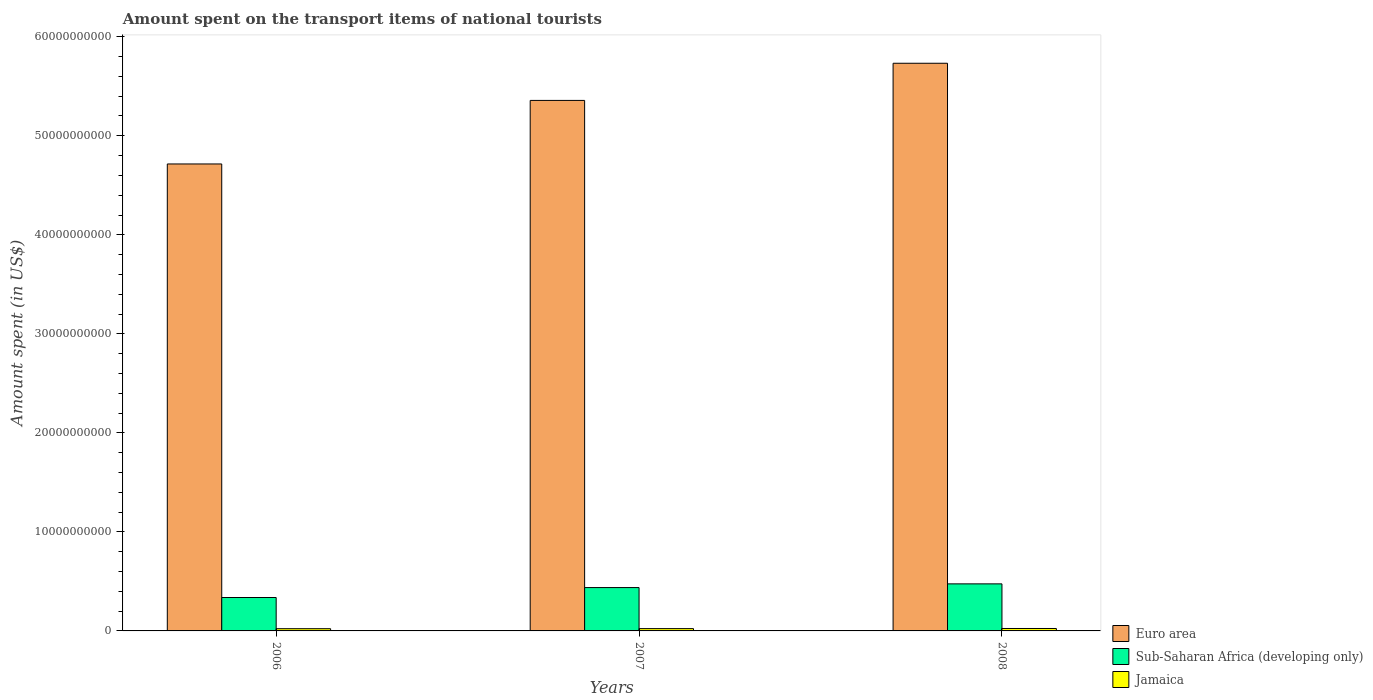Are the number of bars per tick equal to the number of legend labels?
Offer a very short reply. Yes. How many bars are there on the 3rd tick from the left?
Make the answer very short. 3. How many bars are there on the 2nd tick from the right?
Provide a short and direct response. 3. What is the amount spent on the transport items of national tourists in Jamaica in 2007?
Provide a short and direct response. 2.32e+08. Across all years, what is the maximum amount spent on the transport items of national tourists in Euro area?
Keep it short and to the point. 5.73e+1. Across all years, what is the minimum amount spent on the transport items of national tourists in Jamaica?
Provide a short and direct response. 2.24e+08. In which year was the amount spent on the transport items of national tourists in Euro area maximum?
Keep it short and to the point. 2008. In which year was the amount spent on the transport items of national tourists in Euro area minimum?
Offer a terse response. 2006. What is the total amount spent on the transport items of national tourists in Sub-Saharan Africa (developing only) in the graph?
Your answer should be compact. 1.25e+1. What is the difference between the amount spent on the transport items of national tourists in Euro area in 2006 and that in 2007?
Your response must be concise. -6.42e+09. What is the difference between the amount spent on the transport items of national tourists in Sub-Saharan Africa (developing only) in 2008 and the amount spent on the transport items of national tourists in Jamaica in 2006?
Give a very brief answer. 4.53e+09. What is the average amount spent on the transport items of national tourists in Jamaica per year?
Ensure brevity in your answer.  2.34e+08. In the year 2006, what is the difference between the amount spent on the transport items of national tourists in Euro area and amount spent on the transport items of national tourists in Sub-Saharan Africa (developing only)?
Offer a terse response. 4.38e+1. What is the ratio of the amount spent on the transport items of national tourists in Jamaica in 2007 to that in 2008?
Your response must be concise. 0.94. Is the difference between the amount spent on the transport items of national tourists in Euro area in 2006 and 2007 greater than the difference between the amount spent on the transport items of national tourists in Sub-Saharan Africa (developing only) in 2006 and 2007?
Provide a succinct answer. No. What is the difference between the highest and the second highest amount spent on the transport items of national tourists in Sub-Saharan Africa (developing only)?
Provide a succinct answer. 3.73e+08. What is the difference between the highest and the lowest amount spent on the transport items of national tourists in Euro area?
Give a very brief answer. 1.02e+1. In how many years, is the amount spent on the transport items of national tourists in Euro area greater than the average amount spent on the transport items of national tourists in Euro area taken over all years?
Make the answer very short. 2. What does the 2nd bar from the left in 2007 represents?
Your response must be concise. Sub-Saharan Africa (developing only). What does the 3rd bar from the right in 2006 represents?
Give a very brief answer. Euro area. How many years are there in the graph?
Give a very brief answer. 3. Are the values on the major ticks of Y-axis written in scientific E-notation?
Keep it short and to the point. No. Does the graph contain grids?
Your response must be concise. No. How are the legend labels stacked?
Ensure brevity in your answer.  Vertical. What is the title of the graph?
Your answer should be compact. Amount spent on the transport items of national tourists. Does "Portugal" appear as one of the legend labels in the graph?
Offer a very short reply. No. What is the label or title of the X-axis?
Offer a very short reply. Years. What is the label or title of the Y-axis?
Provide a short and direct response. Amount spent (in US$). What is the Amount spent (in US$) in Euro area in 2006?
Provide a succinct answer. 4.72e+1. What is the Amount spent (in US$) in Sub-Saharan Africa (developing only) in 2006?
Your answer should be compact. 3.37e+09. What is the Amount spent (in US$) of Jamaica in 2006?
Provide a succinct answer. 2.24e+08. What is the Amount spent (in US$) in Euro area in 2007?
Provide a short and direct response. 5.36e+1. What is the Amount spent (in US$) in Sub-Saharan Africa (developing only) in 2007?
Keep it short and to the point. 4.38e+09. What is the Amount spent (in US$) of Jamaica in 2007?
Offer a terse response. 2.32e+08. What is the Amount spent (in US$) of Euro area in 2008?
Your response must be concise. 5.73e+1. What is the Amount spent (in US$) in Sub-Saharan Africa (developing only) in 2008?
Your response must be concise. 4.75e+09. What is the Amount spent (in US$) in Jamaica in 2008?
Offer a terse response. 2.46e+08. Across all years, what is the maximum Amount spent (in US$) in Euro area?
Give a very brief answer. 5.73e+1. Across all years, what is the maximum Amount spent (in US$) of Sub-Saharan Africa (developing only)?
Your answer should be compact. 4.75e+09. Across all years, what is the maximum Amount spent (in US$) in Jamaica?
Offer a terse response. 2.46e+08. Across all years, what is the minimum Amount spent (in US$) in Euro area?
Keep it short and to the point. 4.72e+1. Across all years, what is the minimum Amount spent (in US$) in Sub-Saharan Africa (developing only)?
Provide a succinct answer. 3.37e+09. Across all years, what is the minimum Amount spent (in US$) in Jamaica?
Provide a short and direct response. 2.24e+08. What is the total Amount spent (in US$) in Euro area in the graph?
Ensure brevity in your answer.  1.58e+11. What is the total Amount spent (in US$) in Sub-Saharan Africa (developing only) in the graph?
Your answer should be very brief. 1.25e+1. What is the total Amount spent (in US$) of Jamaica in the graph?
Provide a short and direct response. 7.02e+08. What is the difference between the Amount spent (in US$) of Euro area in 2006 and that in 2007?
Give a very brief answer. -6.42e+09. What is the difference between the Amount spent (in US$) of Sub-Saharan Africa (developing only) in 2006 and that in 2007?
Your answer should be very brief. -1.00e+09. What is the difference between the Amount spent (in US$) of Jamaica in 2006 and that in 2007?
Offer a terse response. -8.00e+06. What is the difference between the Amount spent (in US$) of Euro area in 2006 and that in 2008?
Make the answer very short. -1.02e+1. What is the difference between the Amount spent (in US$) of Sub-Saharan Africa (developing only) in 2006 and that in 2008?
Your response must be concise. -1.38e+09. What is the difference between the Amount spent (in US$) of Jamaica in 2006 and that in 2008?
Provide a succinct answer. -2.20e+07. What is the difference between the Amount spent (in US$) of Euro area in 2007 and that in 2008?
Your response must be concise. -3.75e+09. What is the difference between the Amount spent (in US$) in Sub-Saharan Africa (developing only) in 2007 and that in 2008?
Give a very brief answer. -3.73e+08. What is the difference between the Amount spent (in US$) in Jamaica in 2007 and that in 2008?
Give a very brief answer. -1.40e+07. What is the difference between the Amount spent (in US$) in Euro area in 2006 and the Amount spent (in US$) in Sub-Saharan Africa (developing only) in 2007?
Provide a succinct answer. 4.28e+1. What is the difference between the Amount spent (in US$) of Euro area in 2006 and the Amount spent (in US$) of Jamaica in 2007?
Offer a very short reply. 4.69e+1. What is the difference between the Amount spent (in US$) in Sub-Saharan Africa (developing only) in 2006 and the Amount spent (in US$) in Jamaica in 2007?
Provide a short and direct response. 3.14e+09. What is the difference between the Amount spent (in US$) in Euro area in 2006 and the Amount spent (in US$) in Sub-Saharan Africa (developing only) in 2008?
Offer a very short reply. 4.24e+1. What is the difference between the Amount spent (in US$) of Euro area in 2006 and the Amount spent (in US$) of Jamaica in 2008?
Your answer should be compact. 4.69e+1. What is the difference between the Amount spent (in US$) in Sub-Saharan Africa (developing only) in 2006 and the Amount spent (in US$) in Jamaica in 2008?
Offer a terse response. 3.13e+09. What is the difference between the Amount spent (in US$) in Euro area in 2007 and the Amount spent (in US$) in Sub-Saharan Africa (developing only) in 2008?
Offer a terse response. 4.88e+1. What is the difference between the Amount spent (in US$) of Euro area in 2007 and the Amount spent (in US$) of Jamaica in 2008?
Provide a short and direct response. 5.33e+1. What is the difference between the Amount spent (in US$) of Sub-Saharan Africa (developing only) in 2007 and the Amount spent (in US$) of Jamaica in 2008?
Ensure brevity in your answer.  4.13e+09. What is the average Amount spent (in US$) of Euro area per year?
Offer a terse response. 5.27e+1. What is the average Amount spent (in US$) in Sub-Saharan Africa (developing only) per year?
Give a very brief answer. 4.17e+09. What is the average Amount spent (in US$) in Jamaica per year?
Ensure brevity in your answer.  2.34e+08. In the year 2006, what is the difference between the Amount spent (in US$) of Euro area and Amount spent (in US$) of Sub-Saharan Africa (developing only)?
Provide a short and direct response. 4.38e+1. In the year 2006, what is the difference between the Amount spent (in US$) of Euro area and Amount spent (in US$) of Jamaica?
Your response must be concise. 4.69e+1. In the year 2006, what is the difference between the Amount spent (in US$) of Sub-Saharan Africa (developing only) and Amount spent (in US$) of Jamaica?
Your answer should be compact. 3.15e+09. In the year 2007, what is the difference between the Amount spent (in US$) of Euro area and Amount spent (in US$) of Sub-Saharan Africa (developing only)?
Your answer should be very brief. 4.92e+1. In the year 2007, what is the difference between the Amount spent (in US$) of Euro area and Amount spent (in US$) of Jamaica?
Offer a very short reply. 5.33e+1. In the year 2007, what is the difference between the Amount spent (in US$) in Sub-Saharan Africa (developing only) and Amount spent (in US$) in Jamaica?
Provide a succinct answer. 4.15e+09. In the year 2008, what is the difference between the Amount spent (in US$) in Euro area and Amount spent (in US$) in Sub-Saharan Africa (developing only)?
Give a very brief answer. 5.26e+1. In the year 2008, what is the difference between the Amount spent (in US$) in Euro area and Amount spent (in US$) in Jamaica?
Offer a very short reply. 5.71e+1. In the year 2008, what is the difference between the Amount spent (in US$) of Sub-Saharan Africa (developing only) and Amount spent (in US$) of Jamaica?
Keep it short and to the point. 4.51e+09. What is the ratio of the Amount spent (in US$) of Euro area in 2006 to that in 2007?
Give a very brief answer. 0.88. What is the ratio of the Amount spent (in US$) of Sub-Saharan Africa (developing only) in 2006 to that in 2007?
Provide a short and direct response. 0.77. What is the ratio of the Amount spent (in US$) in Jamaica in 2006 to that in 2007?
Give a very brief answer. 0.97. What is the ratio of the Amount spent (in US$) of Euro area in 2006 to that in 2008?
Ensure brevity in your answer.  0.82. What is the ratio of the Amount spent (in US$) in Sub-Saharan Africa (developing only) in 2006 to that in 2008?
Your answer should be compact. 0.71. What is the ratio of the Amount spent (in US$) of Jamaica in 2006 to that in 2008?
Your answer should be very brief. 0.91. What is the ratio of the Amount spent (in US$) of Euro area in 2007 to that in 2008?
Offer a very short reply. 0.93. What is the ratio of the Amount spent (in US$) of Sub-Saharan Africa (developing only) in 2007 to that in 2008?
Your response must be concise. 0.92. What is the ratio of the Amount spent (in US$) in Jamaica in 2007 to that in 2008?
Your response must be concise. 0.94. What is the difference between the highest and the second highest Amount spent (in US$) of Euro area?
Offer a very short reply. 3.75e+09. What is the difference between the highest and the second highest Amount spent (in US$) in Sub-Saharan Africa (developing only)?
Your answer should be compact. 3.73e+08. What is the difference between the highest and the second highest Amount spent (in US$) of Jamaica?
Your answer should be compact. 1.40e+07. What is the difference between the highest and the lowest Amount spent (in US$) of Euro area?
Make the answer very short. 1.02e+1. What is the difference between the highest and the lowest Amount spent (in US$) of Sub-Saharan Africa (developing only)?
Offer a terse response. 1.38e+09. What is the difference between the highest and the lowest Amount spent (in US$) in Jamaica?
Offer a terse response. 2.20e+07. 